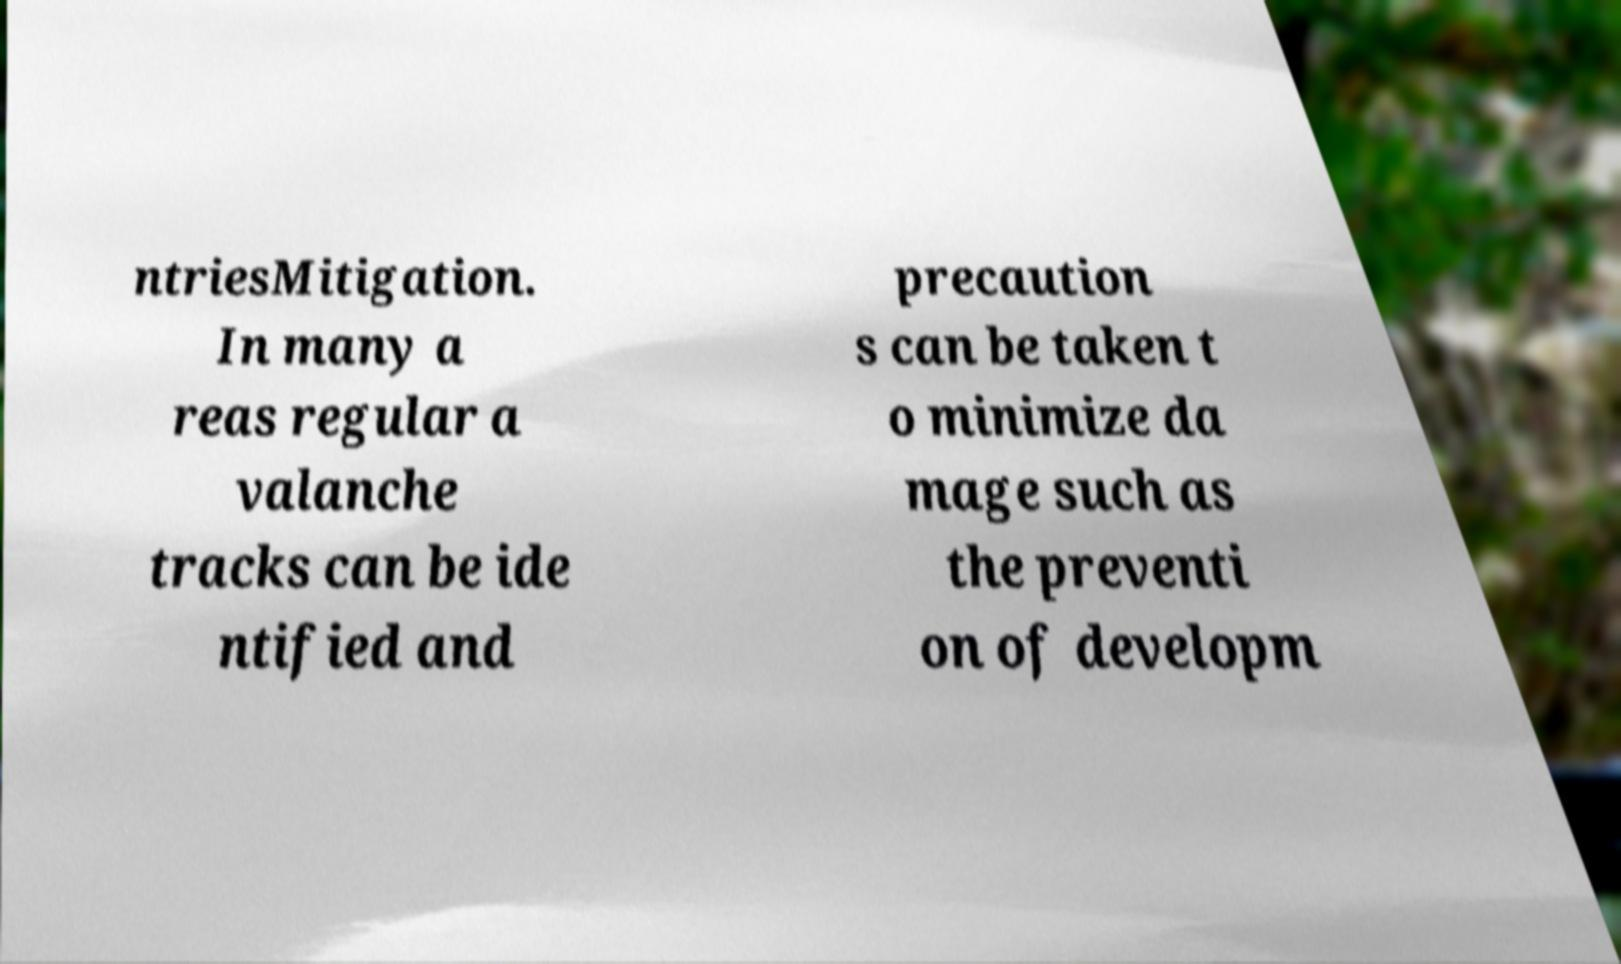Can you read and provide the text displayed in the image?This photo seems to have some interesting text. Can you extract and type it out for me? ntriesMitigation. In many a reas regular a valanche tracks can be ide ntified and precaution s can be taken t o minimize da mage such as the preventi on of developm 